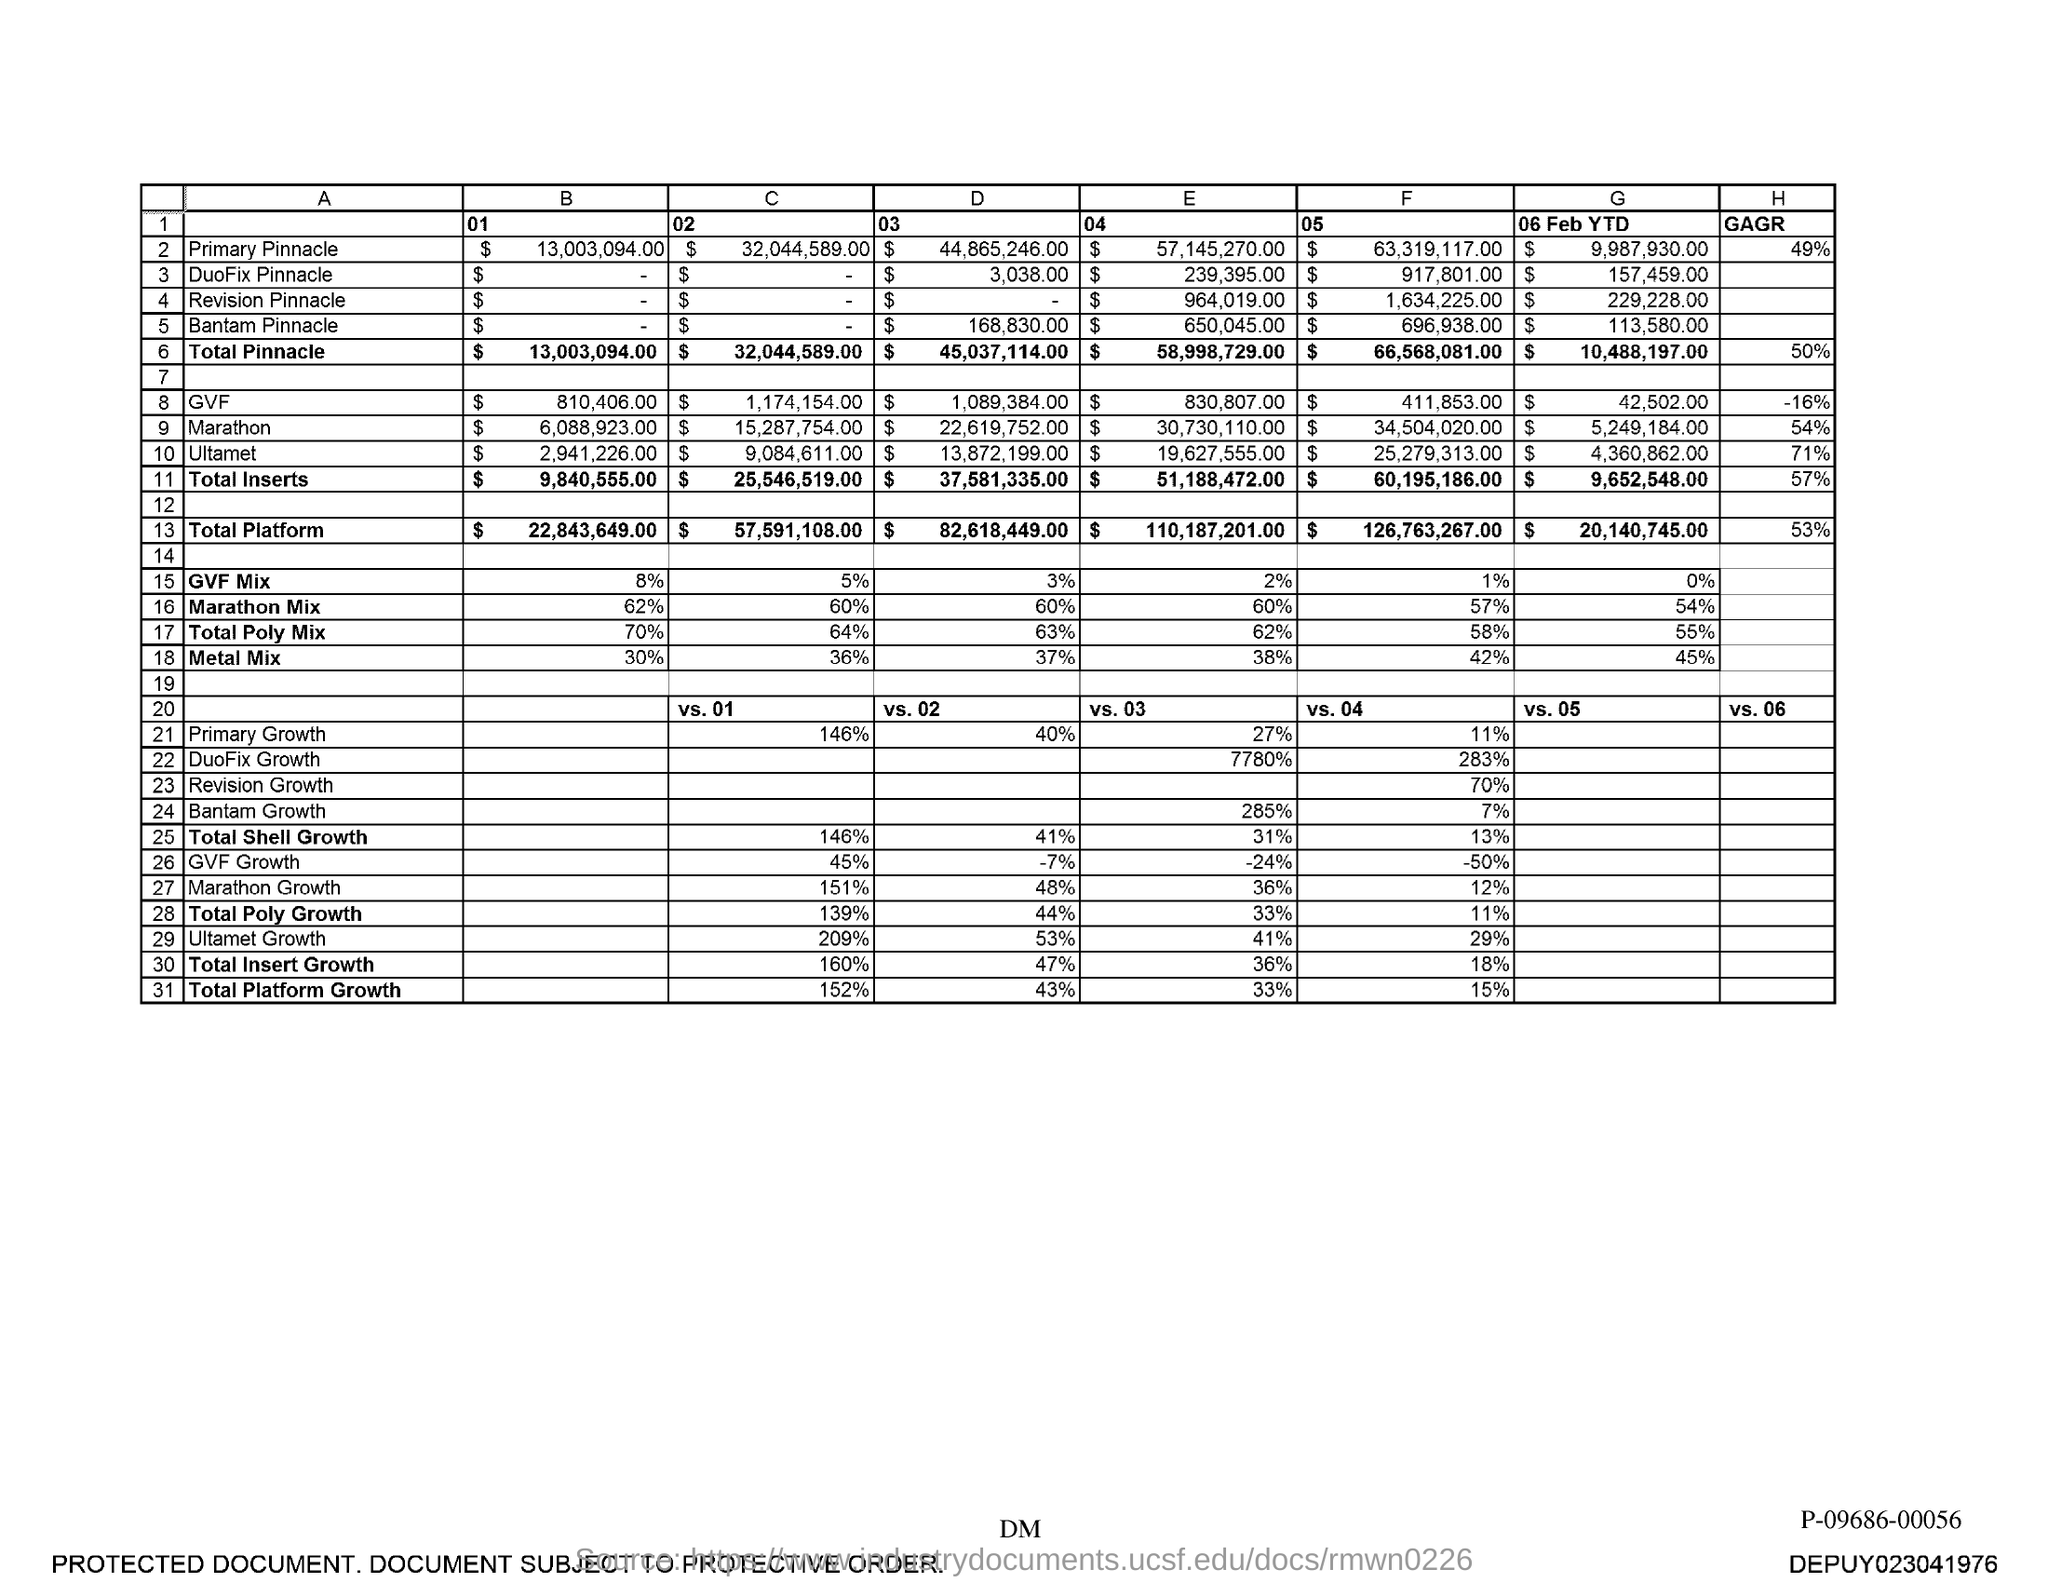Give some essential details in this illustration. The D03 value for Duofix Pinnacle is $3,038.00. The value for Total Pinnacle is 58,998,729.00. The value of Primary Pinnacle is $63,319,117.00, as indicated by the letter 'F' followed by the number '05'. The value for Bantam Pinnacle, as indicated by the "D" "03" listing, is $168,830.00. The value of "E" for Bantam Pinnacle is "$650,045.00". 